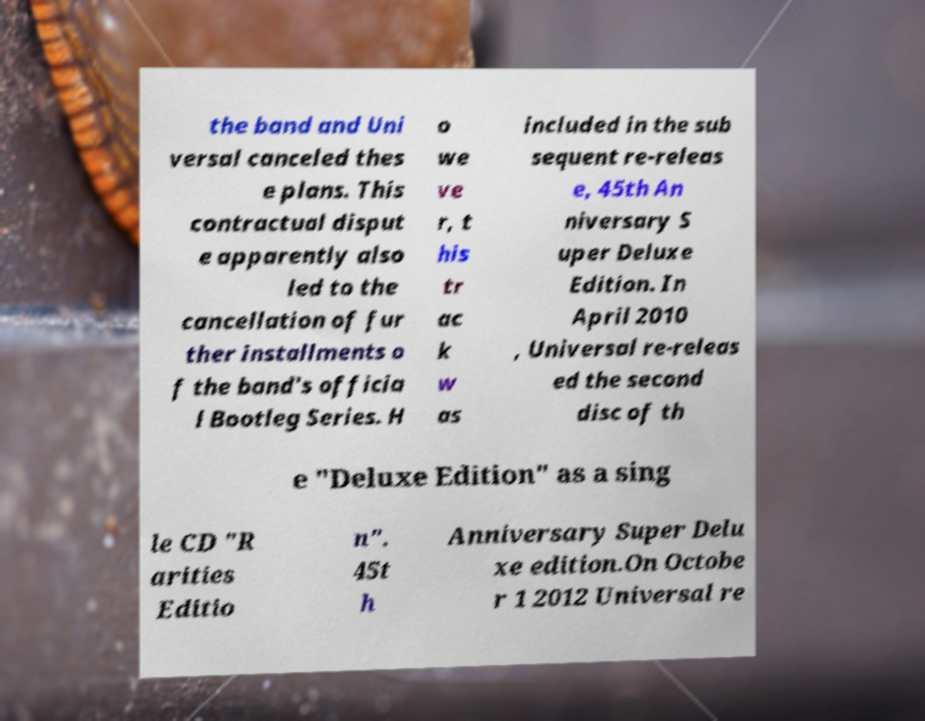Could you extract and type out the text from this image? the band and Uni versal canceled thes e plans. This contractual disput e apparently also led to the cancellation of fur ther installments o f the band's officia l Bootleg Series. H o we ve r, t his tr ac k w as included in the sub sequent re-releas e, 45th An niversary S uper Deluxe Edition. In April 2010 , Universal re-releas ed the second disc of th e "Deluxe Edition" as a sing le CD "R arities Editio n". 45t h Anniversary Super Delu xe edition.On Octobe r 1 2012 Universal re 